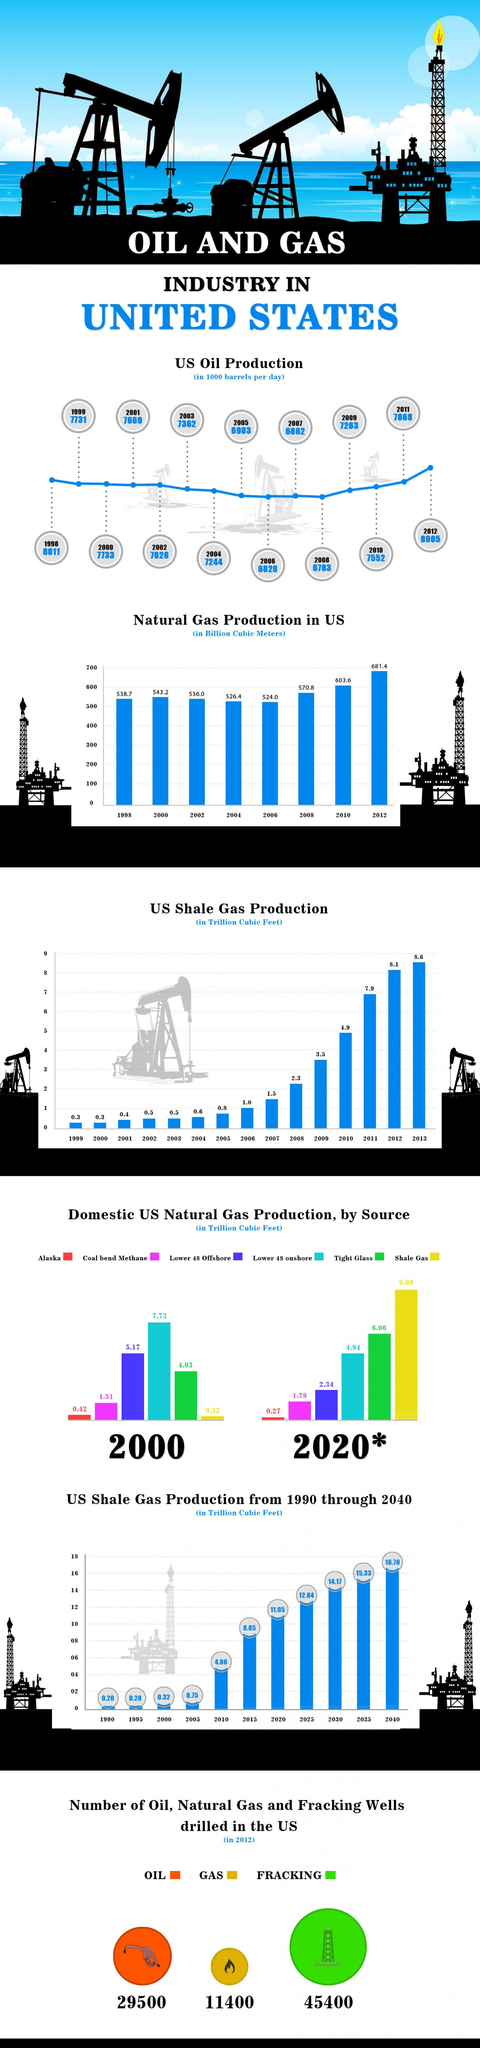Draw attention to some important aspects in this diagram. In 2012, a total of 29,500 oil wells were drilled in the United States. Alaska's domestic natural gas production in 2020 was approximately 0.27 trillion cubic feet. The United States' shale gas production is expected to be the second highest since 1999 in the year. In 2012, there were approximately 45,400 fracking wells drilled in the United States. In the year 2012, a total of 11,400 natural gas wells were drilled in the United States. 